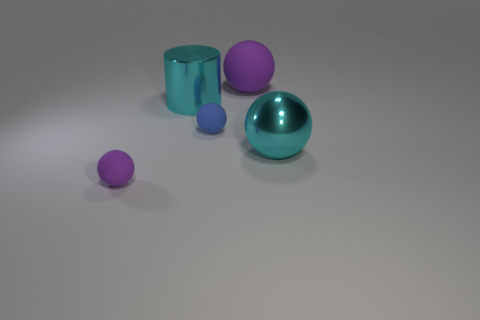Subtract all big cyan spheres. How many spheres are left? 3 Add 3 tiny blue rubber spheres. How many objects exist? 8 Subtract all blue balls. How many balls are left? 3 Subtract all red spheres. Subtract all purple cubes. How many spheres are left? 4 Subtract all cylinders. How many objects are left? 4 Add 4 big blue matte cylinders. How many big blue matte cylinders exist? 4 Subtract 0 purple cubes. How many objects are left? 5 Subtract all tiny brown matte things. Subtract all large objects. How many objects are left? 2 Add 4 purple rubber balls. How many purple rubber balls are left? 6 